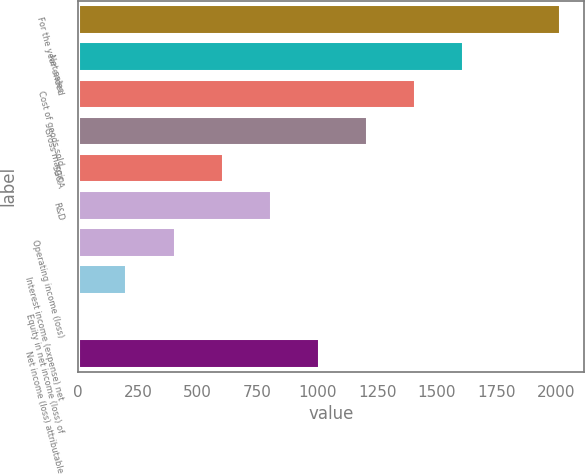Convert chart. <chart><loc_0><loc_0><loc_500><loc_500><bar_chart><fcel>For the year ended<fcel>Net sales<fcel>Cost of goods sold<fcel>Gross margin<fcel>SG&A<fcel>R&D<fcel>Operating income (loss)<fcel>Interest income (expense) net<fcel>Equity in net income (loss) of<fcel>Net income (loss) attributable<nl><fcel>2013<fcel>1610.6<fcel>1409.4<fcel>1208.2<fcel>604.6<fcel>805.8<fcel>403.4<fcel>202.2<fcel>1<fcel>1007<nl></chart> 